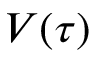Convert formula to latex. <formula><loc_0><loc_0><loc_500><loc_500>V ( \tau )</formula> 